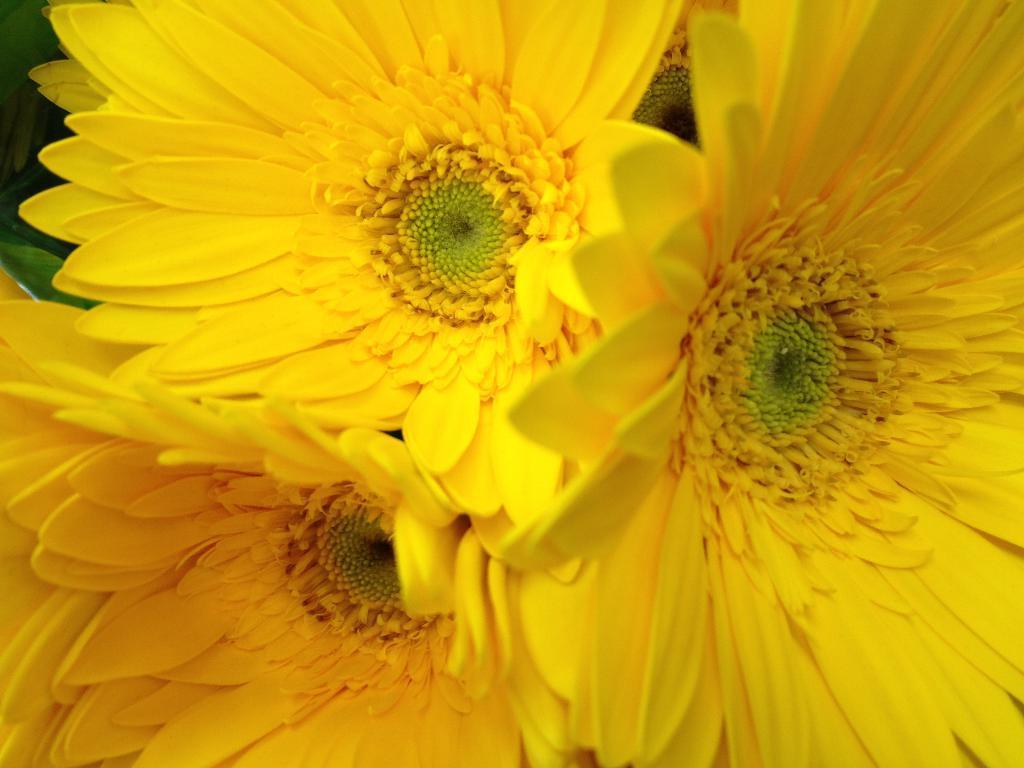Please provide a concise description of this image. As we can see in the image there are yellow color flowers. 